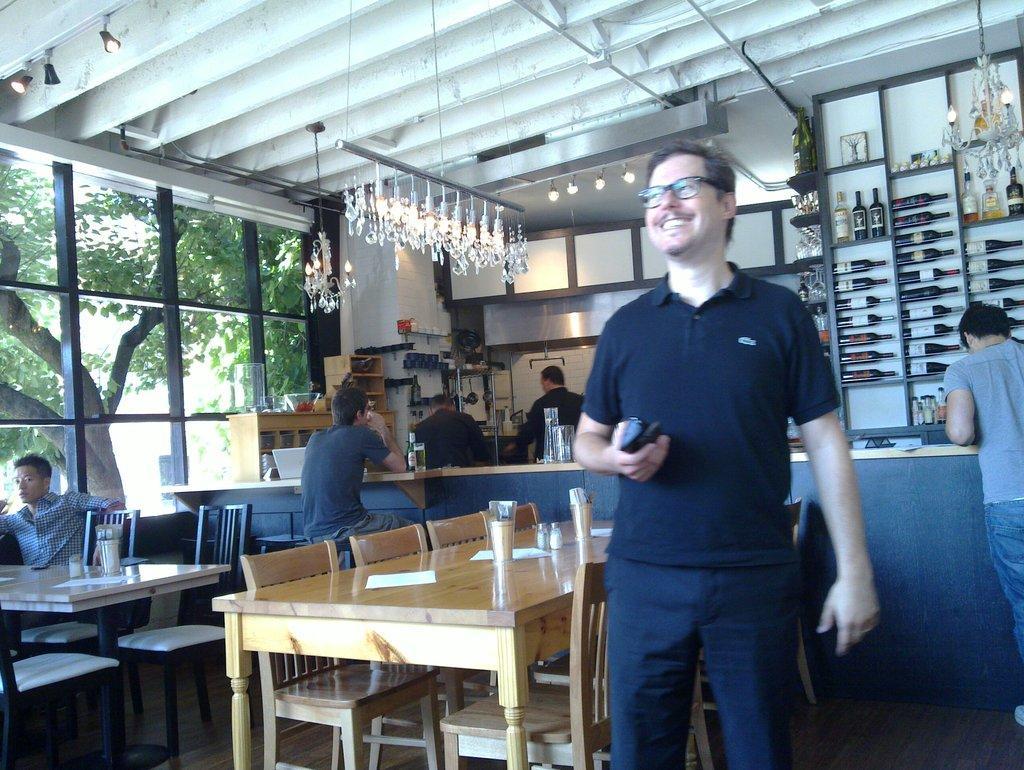Please provide a concise description of this image. In this image I can see few people were two of them are sitting and rest all are standing. Here I can see he is wearing a specs and a smile on his face. In the background I can see few chairs and few tables. On this tablet I can see few glasses. In the background I can see number of bottles and here I can see a tree. 